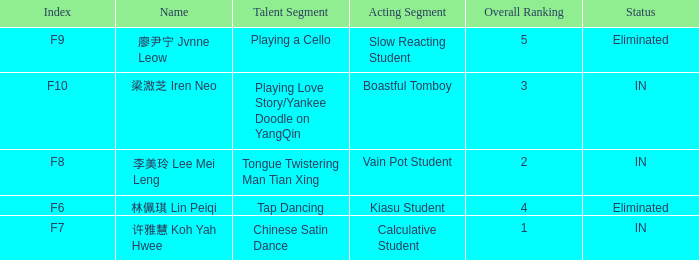For all events with index f10, what is the sum of the overall rankings? 3.0. 